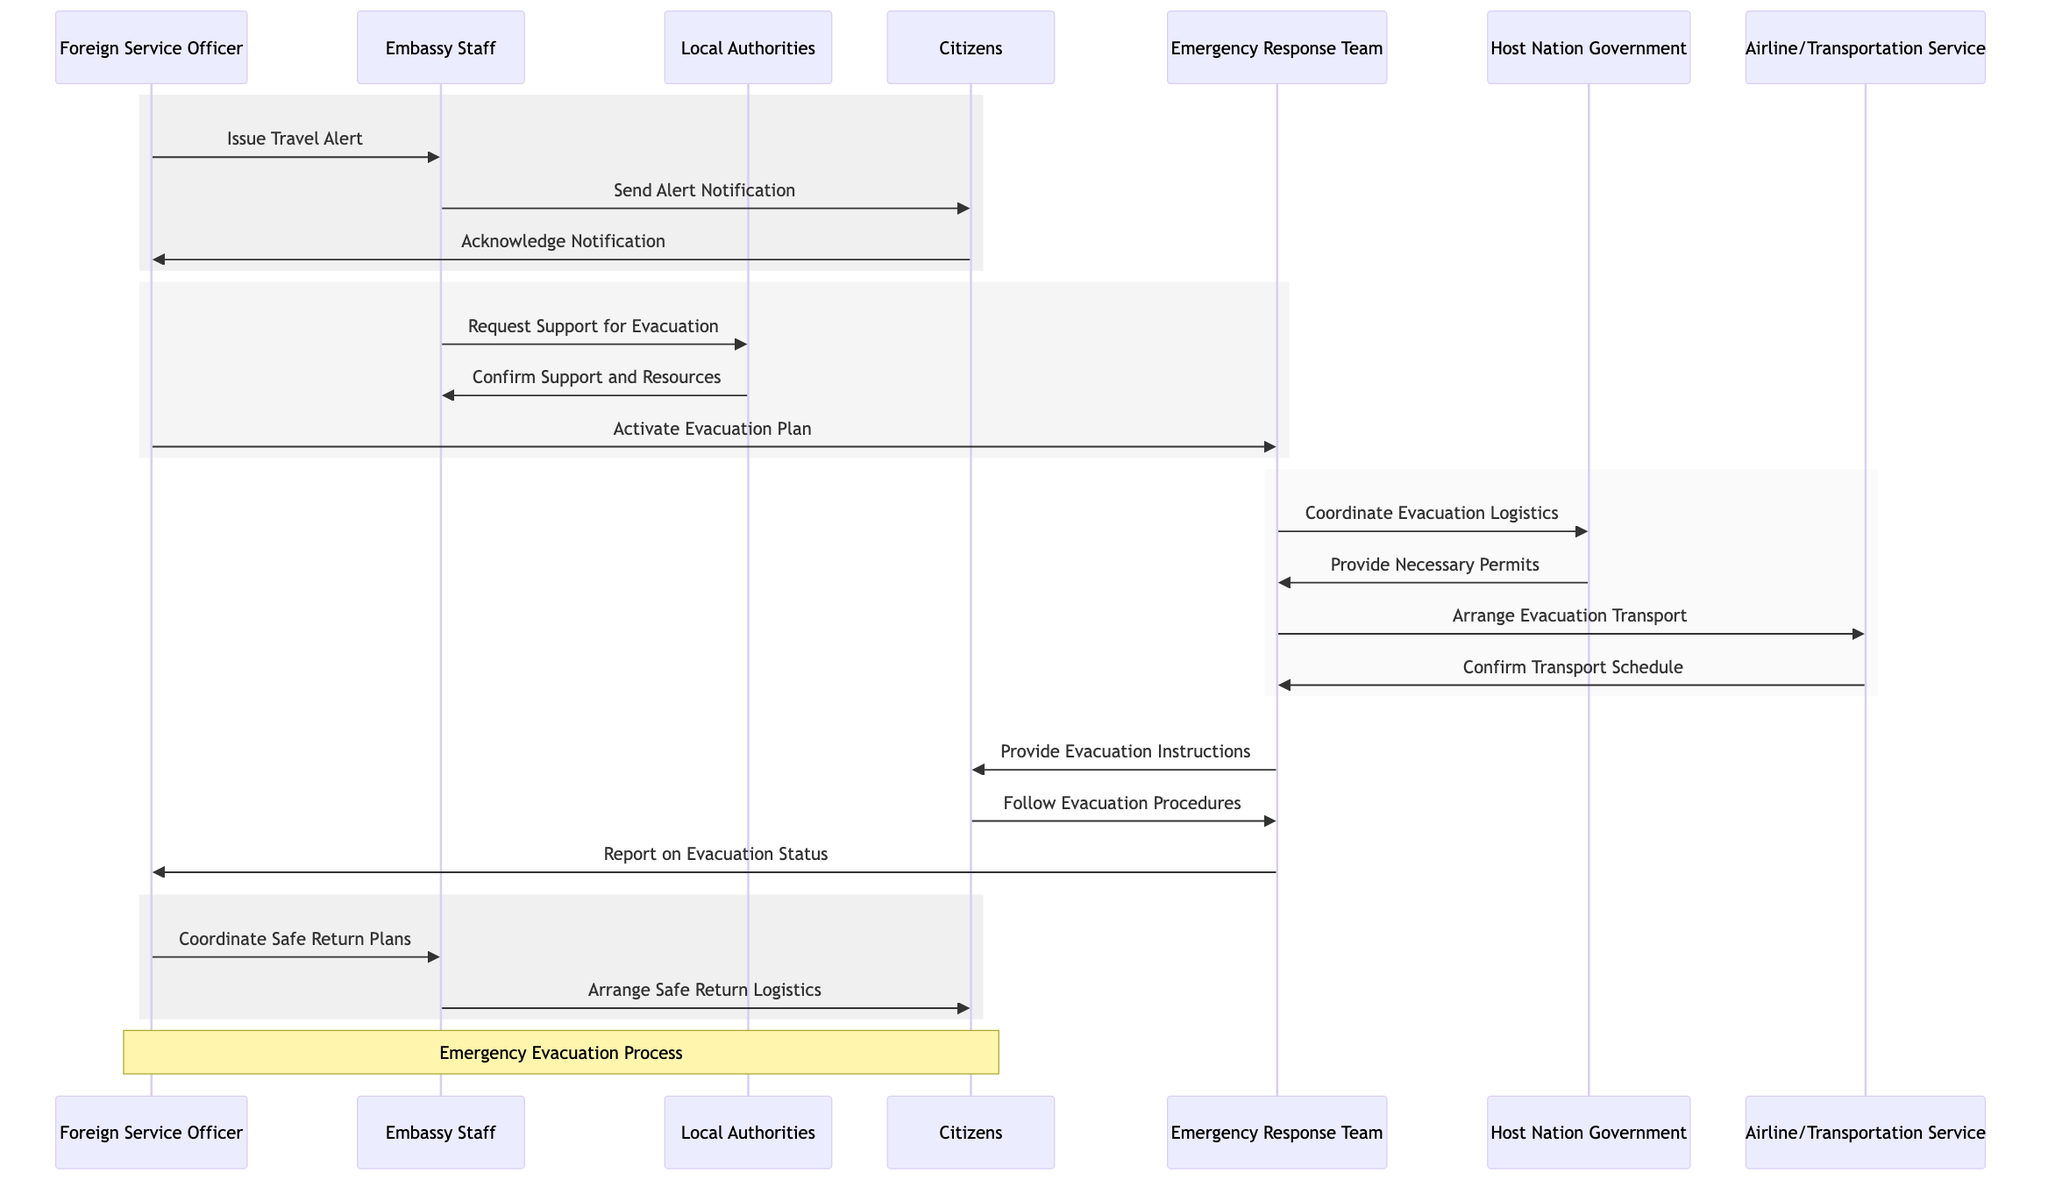What is the first message sent in the evacuation process? The diagram indicates that the first message in the evacuation process is "Issue Travel Alert," which is sent from the Foreign Service Officer to the Embassy Staff.
Answer: Issue Travel Alert How many actors are involved in the evacuation sequence? The diagram lists seven actors involved in the evacuation sequence that includes the Foreign Service Officer, Embassy Staff, Local Authorities, Citizens, Emergency Response Team, Host Nation Government, and Airline/Transportation Service.
Answer: Seven What action is taken by the Embassy Staff after sending the alert notification? Following the alert notification sent to Citizens, the Embassy Staff requests support for evacuation from Local Authorities, as depicted in the subsequent message flow.
Answer: Request Support for Evacuation Who does the Emergency Response Team coordinate with for evacuation logistics? The Emergency Response Team coordinates with the Host Nation Government for evacuation logistics, as shown in their direct message connection in the sequence diagram.
Answer: Host Nation Government What is the final message sent to the Citizens in the evacuation process? The final message sent to the Citizens is "Arrange Safe Return Logistics," which the Embassy Staff sends to them after coordinating the safe return plans by the Foreign Service Officer.
Answer: Arrange Safe Return Logistics What message does the Citizens send after receiving the alert notification? After receiving the alert notification, the Citizens send an acknowledgment back to the Foreign Service Officer, signifying their awareness of the alert and the urgency of the situation.
Answer: Acknowledge Notification What does the Emergency Response Team provide to the Citizens during the evacuation? The Emergency Response Team provides "Evacuation Instructions" to the Citizens, guiding them on how to proceed with the evacuation, as indicated in the diagram.
Answer: Provide Evacuation Instructions What two roles interact directly to confirm support for evacuation? The roles that interact directly to confirm support for evacuation are the Embassy Staff and Local Authorities, as shown by their direct messaging connection in the sequence.
Answer: Embassy Staff and Local Authorities How does the Emergency Response Team update the Foreign Service Officer? The Emergency Response Team updates the Foreign Service Officer by providing a status report on the evacuation process, detailing the progress and any issues encountered along the way.
Answer: Report on Evacuation Status 